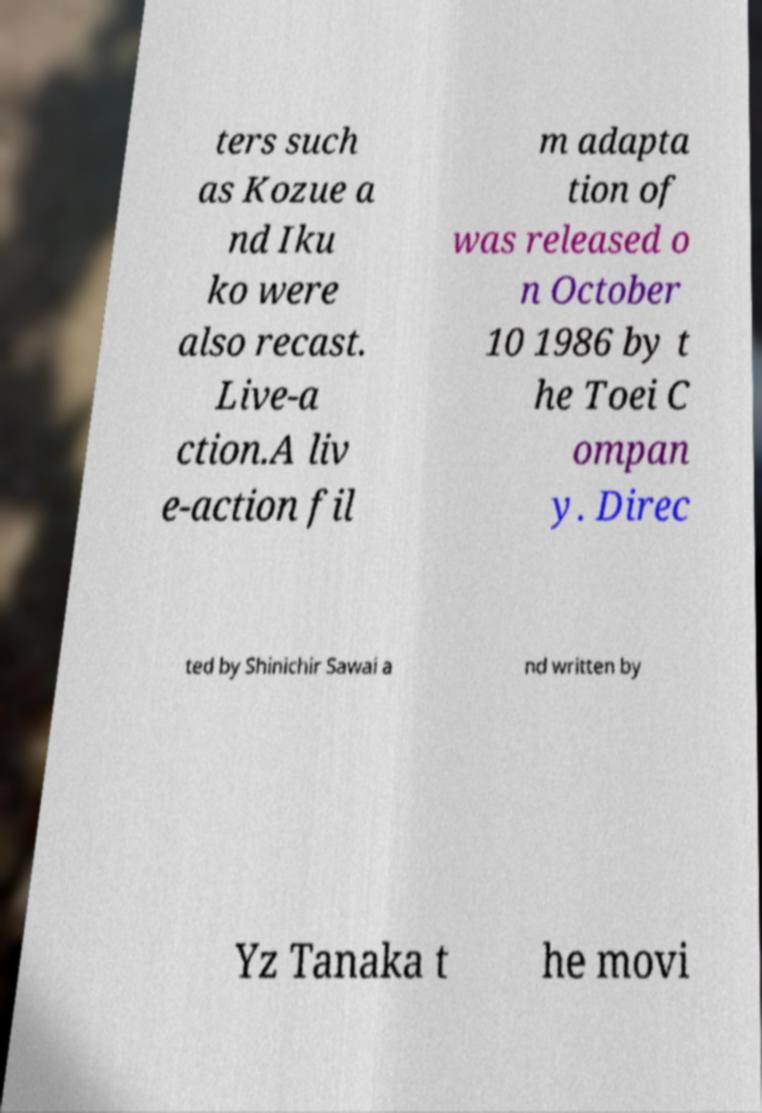Please read and relay the text visible in this image. What does it say? ters such as Kozue a nd Iku ko were also recast. Live-a ction.A liv e-action fil m adapta tion of was released o n October 10 1986 by t he Toei C ompan y. Direc ted by Shinichir Sawai a nd written by Yz Tanaka t he movi 